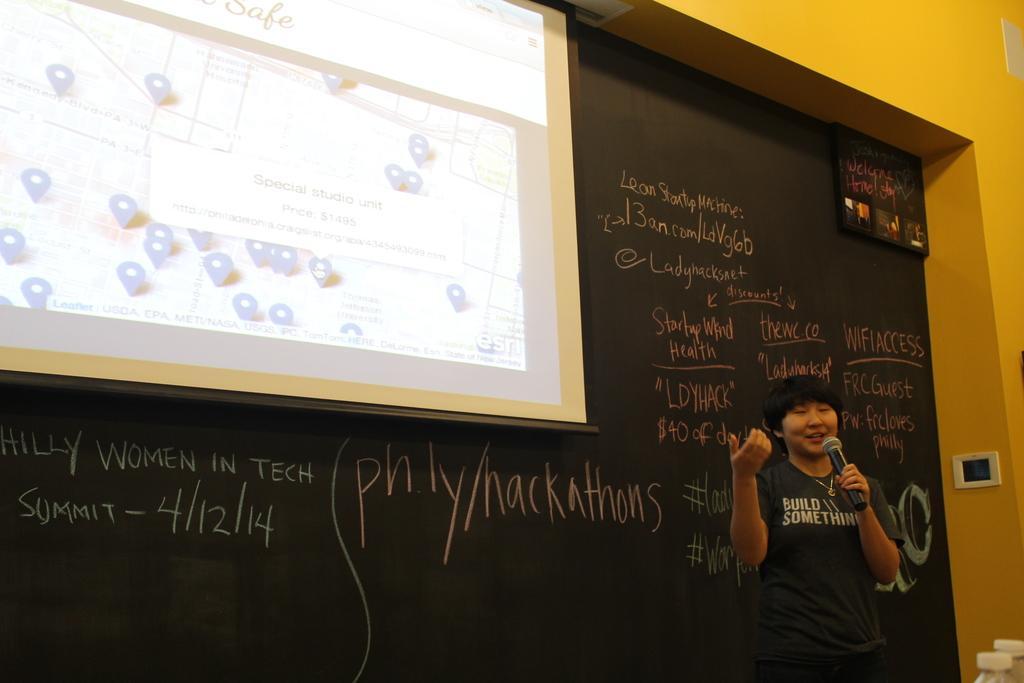Could you give a brief overview of what you see in this image? In a room a person is giving a speech,behind him there is a blackboard and in front of the blackboard there is a projector screen and something is being projected on that screen. Beside the blackboard there is yellow color wall. 